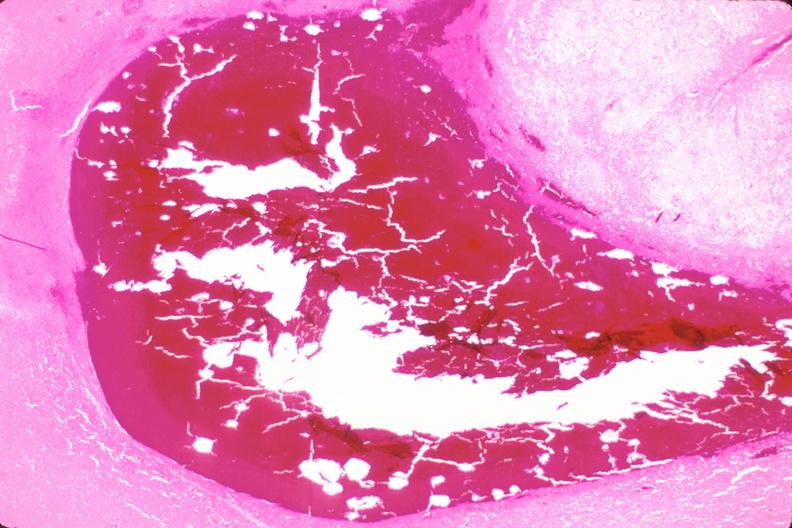what does this image show?
Answer the question using a single word or phrase. Brain 